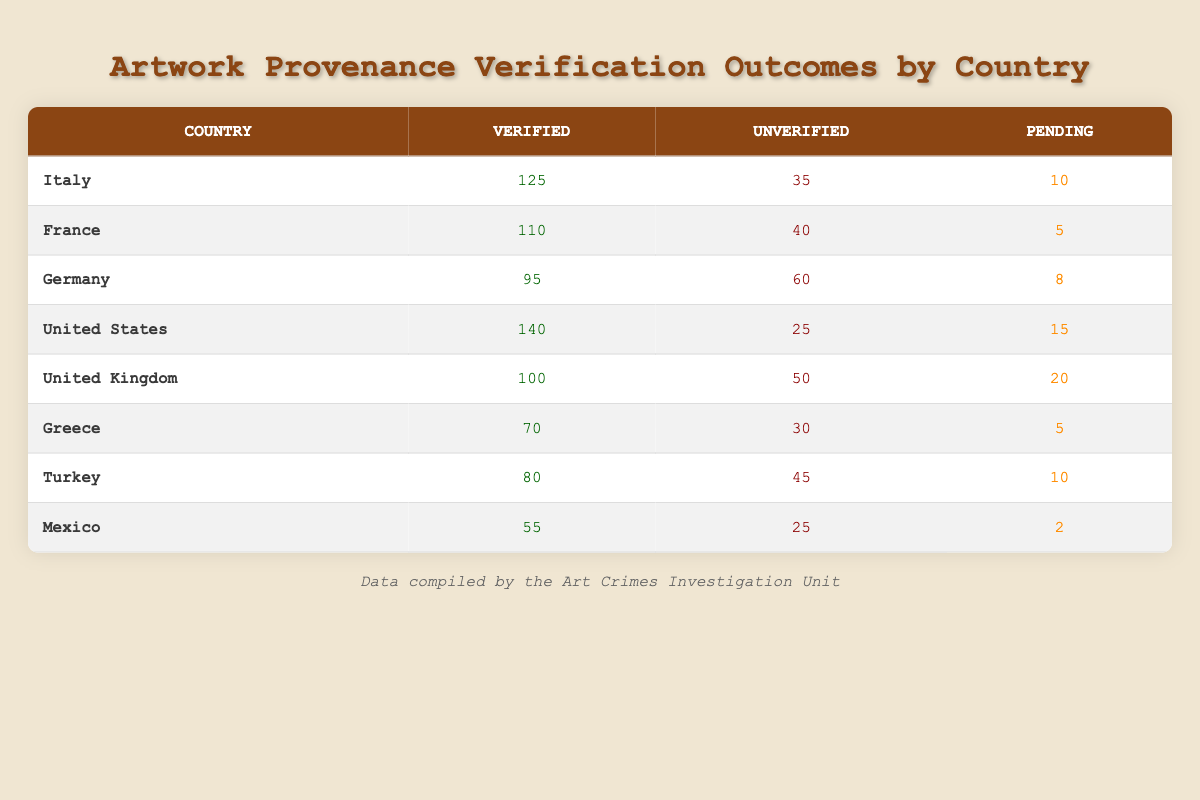What country has the highest number of verified artworks? By reviewing the "Verified" column, I can identify that the United States has the highest value of 140 verified artworks.
Answer: United States What is the total number of unverified artworks across all countries? To find the total, I need to sum the "Unverified" values from each country: 35 + 40 + 60 + 25 + 50 + 30 + 45 + 25 = 310.
Answer: 310 Which country has the highest pending artworks? Looking at the "Pending" column, I see that the United Kingdom has the highest value of 20 pending artworks, compared to other countries.
Answer: United Kingdom Is the number of verified artworks from Italy greater than the total pending artworks in Turkey? Italy has 125 verified artworks, and Turkey has 10 pending artworks. Thus, 125 is indeed greater than 10.
Answer: Yes What is the ratio of verified to unverified artworks for Germany? The number of verified artworks in Germany is 95, and the number of unverified artworks is 60. The ratio is calculated as 95:60, which can be simplified to 19:12 after dividing both numbers by 5.
Answer: 19:12 Which country has the smallest number of verified artworks, and how many does it have? Upon examining the "Verified" column, I can see that Mexico has the smallest value with 55 verified artworks, making it the least in this category.
Answer: Mexico, 55 What is the average number of pending artworks across all countries? To find the average, I will sum the "Pending" values: 10 + 5 + 8 + 15 + 20 + 5 + 10 + 2 = 75 and divide by 8 (the number of countries): 75/8 = 9.375, which can be approximated to 9.4 for practical purposes.
Answer: 9.4 Are there more verified artworks in France than in Greece? France has 110 verified artworks while Greece has 70. Comparing these two values shows that 110 is greater than 70, indicating the statement is true.
Answer: Yes 